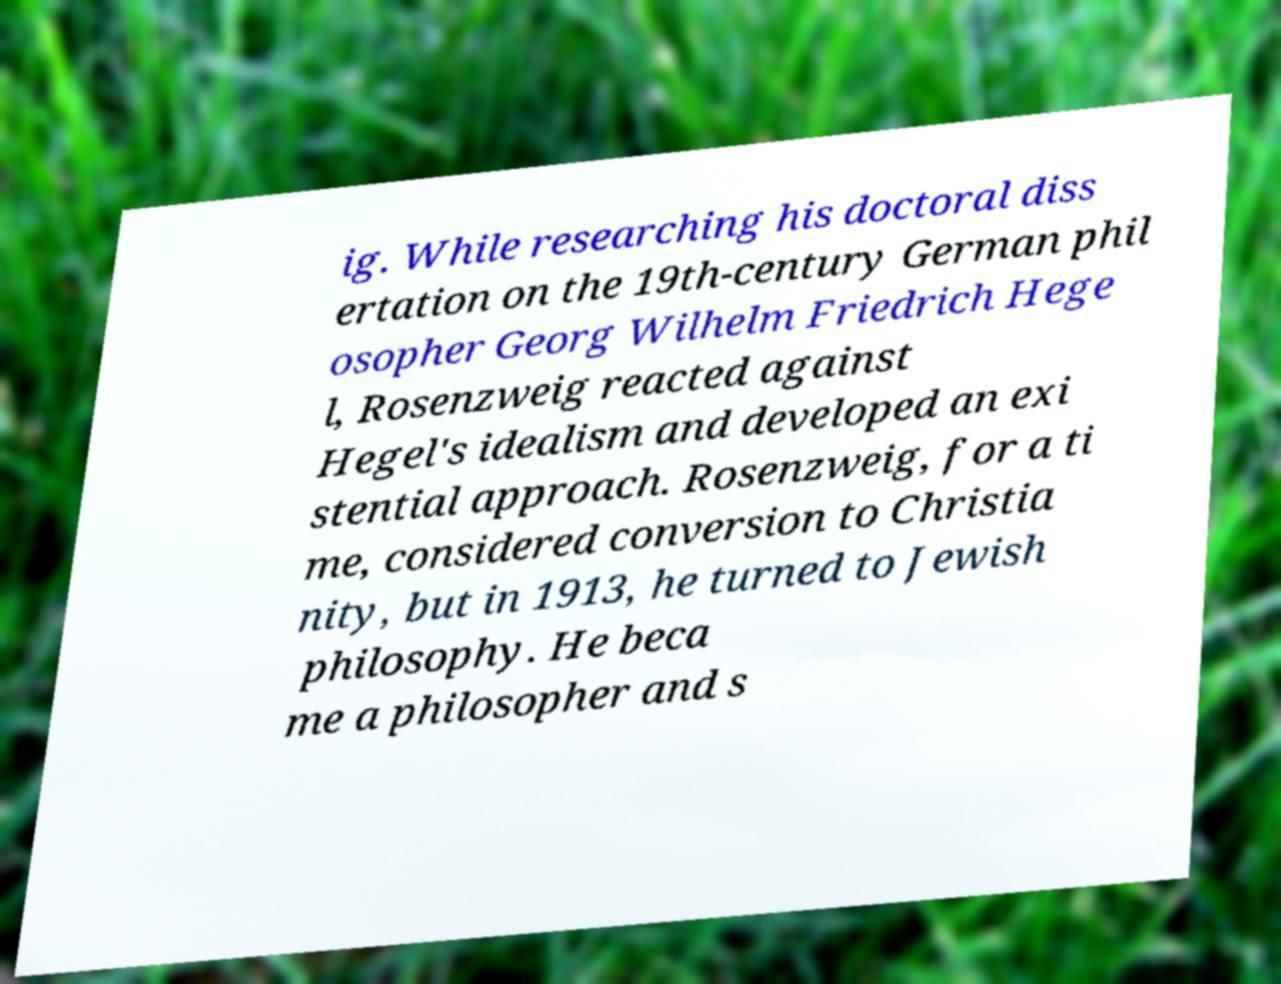Please read and relay the text visible in this image. What does it say? ig. While researching his doctoral diss ertation on the 19th-century German phil osopher Georg Wilhelm Friedrich Hege l, Rosenzweig reacted against Hegel's idealism and developed an exi stential approach. Rosenzweig, for a ti me, considered conversion to Christia nity, but in 1913, he turned to Jewish philosophy. He beca me a philosopher and s 